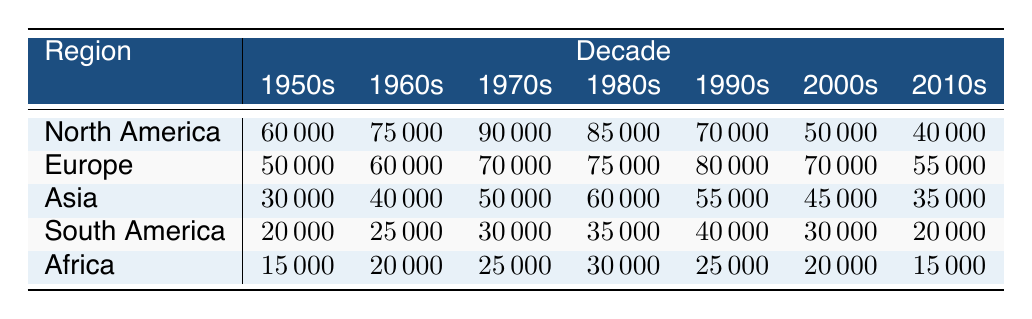What was the circulation of newspapers in North America during the 1980s? The table shows that the circulation of newspapers in North America during the 1980s was 85000.
Answer: 85000 Which region had the highest newspaper circulation in the 1990s? By comparing the values from the table, Europe had the highest circulation of 80000 in the 1990s compared to North America (70000), Asia (55000), South America (40000), and Africa (25000).
Answer: Europe What was the total newspaper circulation in Asia from the 1950s to the 2010s? To find the total circulation in Asia, we add the values: 30000 + 40000 + 50000 + 60000 + 55000 + 45000 + 35000 = 315000.
Answer: 315000 Did South America experience an overall increase in newspaper circulation from the 1950s to the 1990s? We compare the circulation of South America in the 1950s (20000), 1960s (25000), 1970s (30000), 1980s (35000), and 1990s (40000). There is a steady increase in these decades, indicating an overall increase.
Answer: Yes What was the difference in newspaper circulation between the 1950s and 2000s in North America? From the table, the circulation in North America in the 1950s was 60000 and in the 2000s was 50000. The difference is 60000 - 50000 = 10000.
Answer: 10000 Which decade saw the lowest newspaper circulation in Africa? The table indicates that Africa had the lowest circulation of 15000 in the 1950s.
Answer: 1950s Was the newspaper circulation in Europe higher than in North America in the 2000s? In the 2000s, Europe had a circulation of 70000, while North America had 50000. Thus, Europe had a higher circulation than North America in that decade.
Answer: Yes What was the average newspaper circulation in South America during the 1960s and 1970s? For South America, the circulation was 25000 in the 1960s and 30000 in the 1970s. The average is (25000 + 30000) / 2 = 27500.
Answer: 27500 